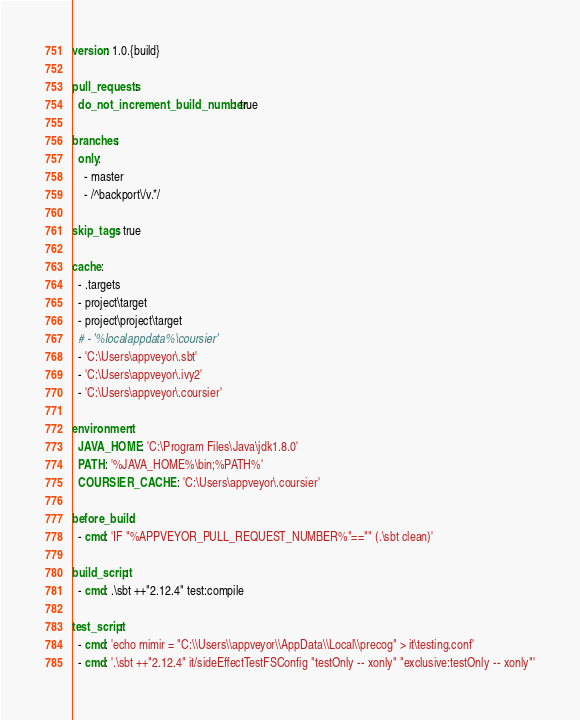<code> <loc_0><loc_0><loc_500><loc_500><_YAML_>version: 1.0.{build}

pull_requests:
  do_not_increment_build_number: true

branches:
  only:
    - master
    - /^backport\/v.*/

skip_tags: true

cache:
  - .targets
  - project\target
  - project\project\target
  # - '%localappdata%\coursier'
  - 'C:\Users\appveyor\.sbt'
  - 'C:\Users\appveyor\.ivy2'
  - 'C:\Users\appveyor\.coursier'

environment:
  JAVA_HOME: 'C:\Program Files\Java\jdk1.8.0'
  PATH: '%JAVA_HOME%\bin;%PATH%'
  COURSIER_CACHE: 'C:\Users\appveyor\.coursier'

before_build:
  - cmd: 'IF "%APPVEYOR_PULL_REQUEST_NUMBER%"=="" (.\sbt clean)'

build_script:
  - cmd: .\sbt ++"2.12.4" test:compile

test_script:
  - cmd: 'echo mimir = "C:\\Users\\appveyor\\AppData\\Local\\precog" > it\testing.conf'
  - cmd: '.\sbt ++"2.12.4" it/sideEffectTestFSConfig "testOnly -- xonly" "exclusive:testOnly -- xonly"'
</code> 